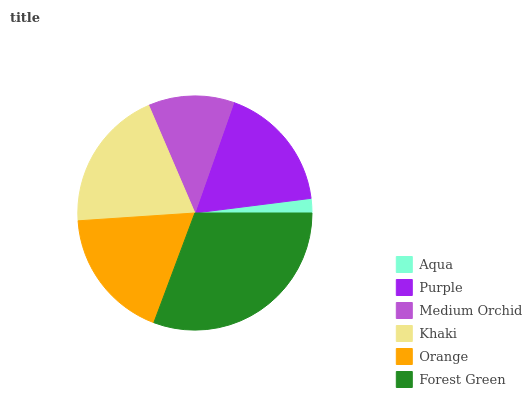Is Aqua the minimum?
Answer yes or no. Yes. Is Forest Green the maximum?
Answer yes or no. Yes. Is Purple the minimum?
Answer yes or no. No. Is Purple the maximum?
Answer yes or no. No. Is Purple greater than Aqua?
Answer yes or no. Yes. Is Aqua less than Purple?
Answer yes or no. Yes. Is Aqua greater than Purple?
Answer yes or no. No. Is Purple less than Aqua?
Answer yes or no. No. Is Orange the high median?
Answer yes or no. Yes. Is Purple the low median?
Answer yes or no. Yes. Is Aqua the high median?
Answer yes or no. No. Is Medium Orchid the low median?
Answer yes or no. No. 